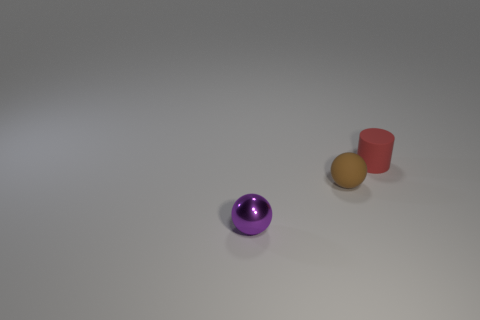There is a object that is right of the metallic sphere and to the left of the small red rubber thing; how big is it?
Make the answer very short. Small. How many other things are the same shape as the brown thing?
Provide a succinct answer. 1. What number of other things are made of the same material as the red cylinder?
Offer a terse response. 1. The purple shiny object that is the same shape as the small brown object is what size?
Your answer should be very brief. Small. Is the tiny matte cylinder the same color as the tiny shiny sphere?
Offer a terse response. No. There is a tiny object that is behind the tiny purple metal thing and in front of the tiny red object; what color is it?
Offer a very short reply. Brown. How many things are small objects that are to the right of the purple metallic ball or small brown cylinders?
Ensure brevity in your answer.  2. There is a small rubber object that is the same shape as the tiny metal thing; what color is it?
Keep it short and to the point. Brown. Do the red matte object and the small thing to the left of the brown thing have the same shape?
Make the answer very short. No. How many things are small spheres behind the shiny object or spheres on the right side of the tiny purple sphere?
Provide a short and direct response. 1. 